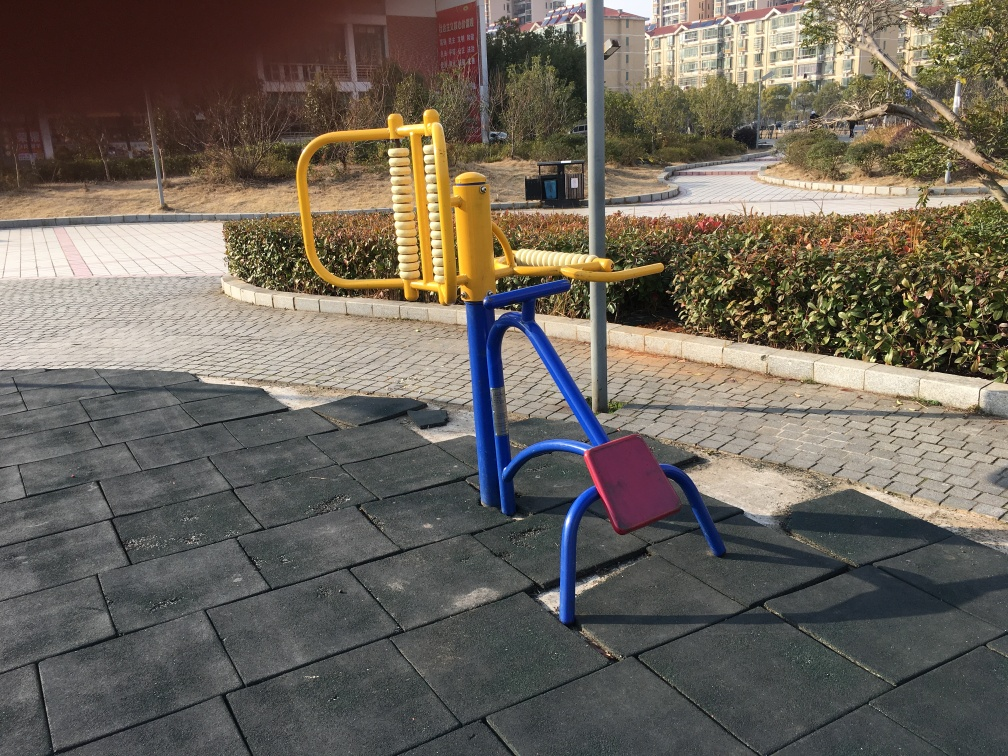What is the color of the image like?
A. Dull
B. Rich
C. Bland
D. Colorless The color of the image can be described as relatively vivid due to the presence of distinct color contrasts such as the bright yellow and blues of the outdoor fitness equipment against the muted background. 